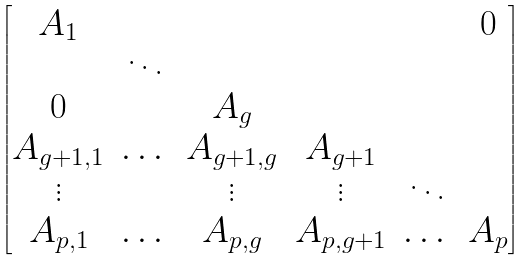Convert formula to latex. <formula><loc_0><loc_0><loc_500><loc_500>\begin{bmatrix} A _ { 1 } & & & & & 0 \\ & \ddots & & & & \\ 0 & & A _ { g } & & & \\ A _ { g + 1 , 1 } & \dots & A _ { g + 1 , g } & A _ { g + 1 } & & \\ \vdots & & \vdots & \vdots & \ddots & \\ A _ { p , 1 } & \dots & A _ { p , g } & A _ { p , g + 1 } & \dots & A _ { p } \\ \end{bmatrix}</formula> 